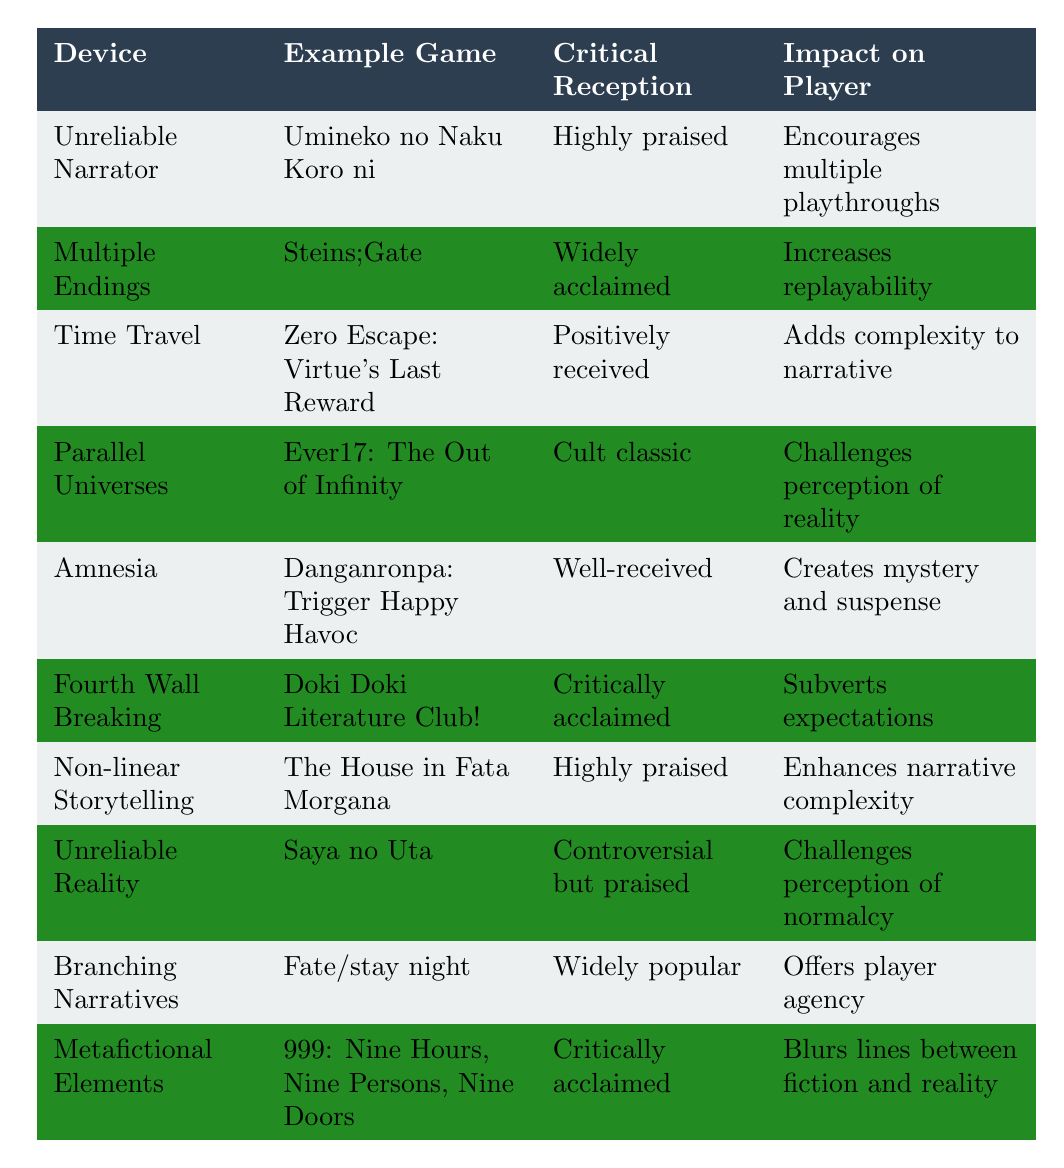What is the critical reception of "Doki Doki Literature Club!"? The table states that "Doki Doki Literature Club!" is "Critically acclaimed" under the "Critical Reception" column.
Answer: Critically acclaimed Which plot device is associated with "Steins;Gate"? According to the table, "Steins;Gate" uses the plot device of "Multiple Endings" as listed in the corresponding row.
Answer: Multiple Endings How many plot devices listed have a critical reception of "Widely acclaimed"? The table indicates that there are two plot devices with a "Widely acclaimed" reception: "Multiple Endings" (Steins;Gate) and "Branching Narratives" (Fate/stay night). Therefore, the total is 2.
Answer: 2 Which game employs the narrative device of "Amnesia"? The game associated with "Amnesia" in the table is "Danganronpa: Trigger Happy Havoc."
Answer: Danganronpa: Trigger Happy Havoc Is "Saya no Uta" received positively according to the table? The critical reception for "Saya no Uta" is noted as "Controversial but praised," which indicates a mixed reception rather than a straightforward positive one.
Answer: No Which narrative devices are designed to encourage player agency? The table indicates that the narrative device "Branching Narratives" encourages player agency by allowing choices to affect the story, as stated in its impact on players.
Answer: Branching Narratives What impact does the "Unreliable Narrator" have on players? The table indicates that the "Unreliable Narrator" encourages multiple playthroughs for players, as noted in its impact description.
Answer: Encourages multiple playthroughs Which plot device is linked to creating mystery and suspense? According to the table, the plot device "Amnesia" is specifically linked to creating "mystery and suspense" for players.
Answer: Amnesia Which game has the narrative device of "Non-linear Storytelling"? "The House in Fata Morgana" employs the narrative device of "Non-linear Storytelling" as listed in the respective row of the table.
Answer: The House in Fata Morgana Out of the listed games, which one has both "Highly praised" critical reception and enhances narrative complexity? The game "The House in Fata Morgana" has a "Highly praised" critical reception and is associated with "Non-linear Storytelling," which enhances narrative complexity, fitting the criteria.
Answer: The House in Fata Morgana 